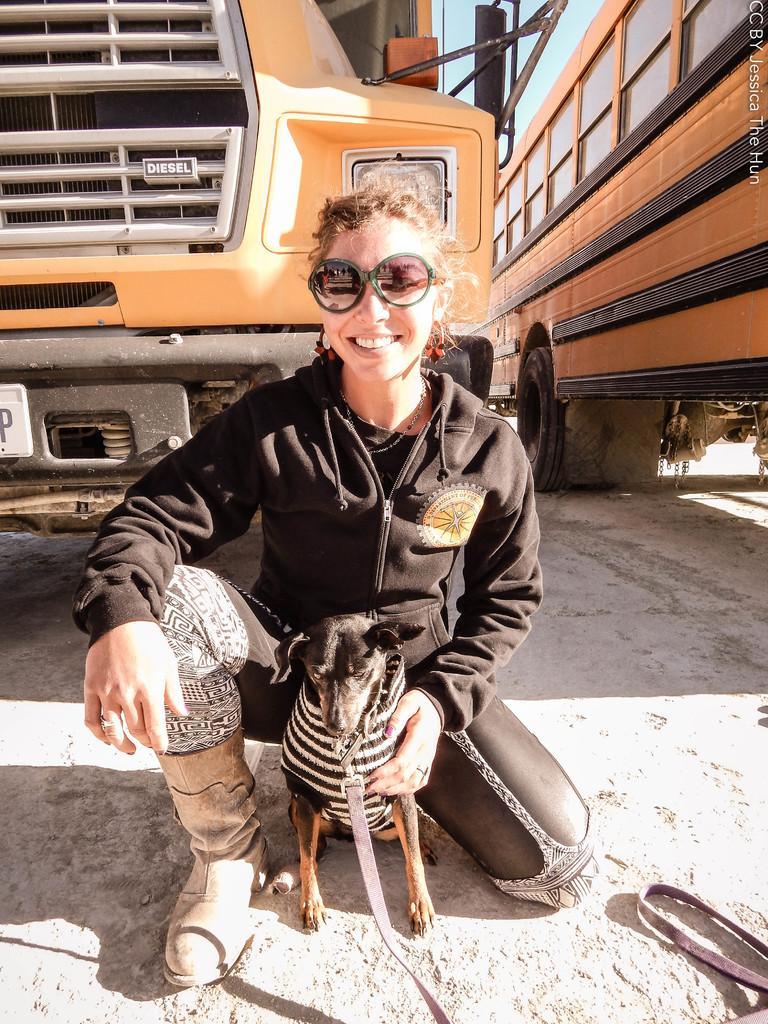In one or two sentences, can you explain what this image depicts? In this image we can see a lady wearing black jacket is having a dog in front of her. In the background we can see two buses. 